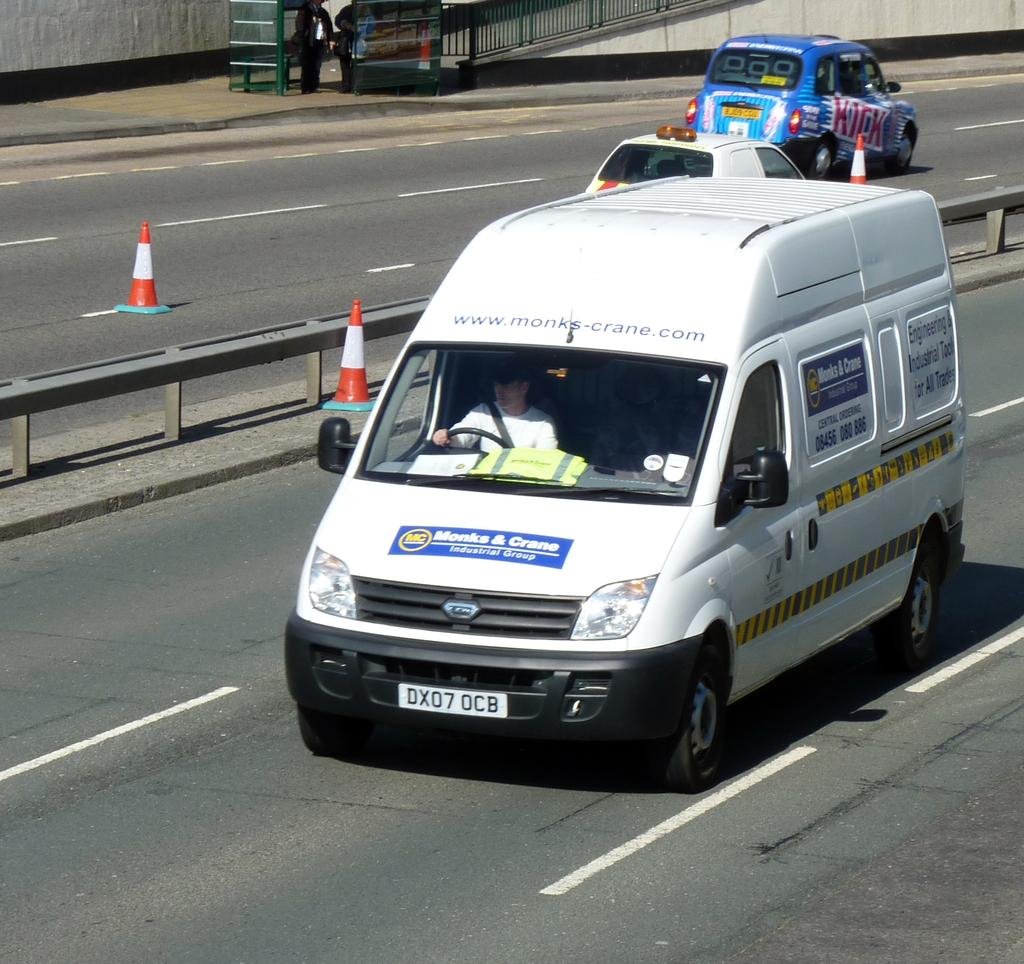<image>
Write a terse but informative summary of the picture. a van with the plate of DX07 OCB 